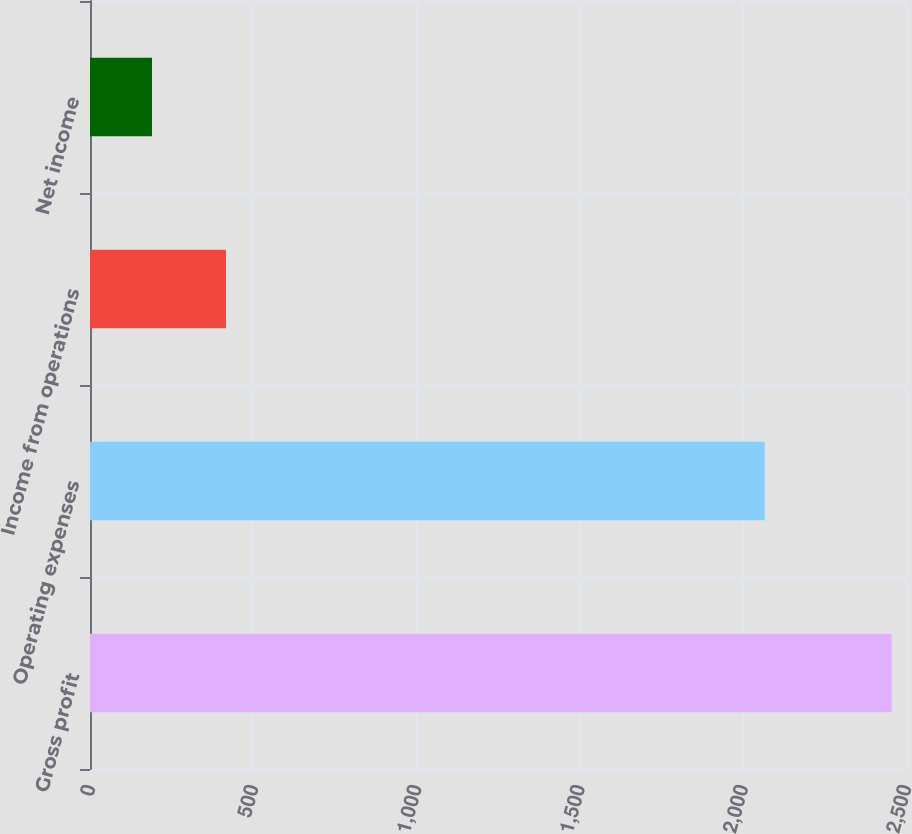Convert chart to OTSL. <chart><loc_0><loc_0><loc_500><loc_500><bar_chart><fcel>Gross profit<fcel>Operating expenses<fcel>Income from operations<fcel>Net income<nl><fcel>2456<fcel>2067<fcel>416.6<fcel>190<nl></chart> 